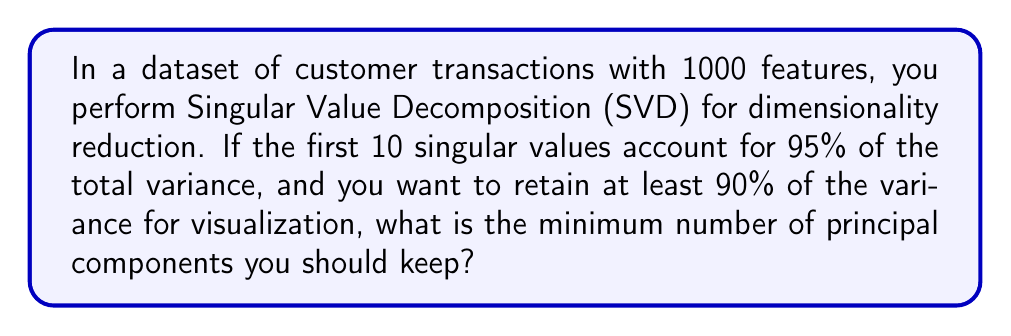Show me your answer to this math problem. Let's approach this step-by-step:

1) In SVD, the singular values represent the amount of variance captured by each principal component. The total variance is the sum of all squared singular values.

2) Let $\sigma_i$ be the $i$-th singular value, and $k$ be the total number of singular values. The total variance is:

   $$\text{Total Variance} = \sum_{i=1}^k \sigma_i^2$$

3) We're told that the first 10 singular values account for 95% of the total variance. This means:

   $$\frac{\sum_{i=1}^{10} \sigma_i^2}{\sum_{i=1}^k \sigma_i^2} = 0.95$$

4) We want to retain at least 90% of the variance. Let $n$ be the number of components we need. We're looking for the smallest $n$ such that:

   $$\frac{\sum_{i=1}^n \sigma_i^2}{\sum_{i=1}^k \sigma_i^2} \geq 0.90$$

5) Since the first 10 components already account for 95% of the variance, which is more than our 90% threshold, we know that $n \leq 10$.

6) The question asks for the minimum number of components, so we need the smallest $n$ that satisfies our condition. This must be less than or equal to 10.

Therefore, the minimum number of principal components to keep is at most 10, but could be less depending on the exact distribution of variance among the first 10 components.
Answer: $\leq 10$ 